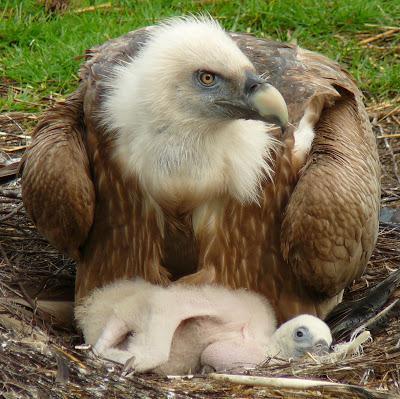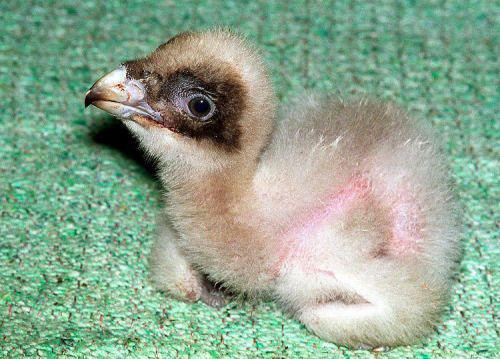The first image is the image on the left, the second image is the image on the right. Evaluate the accuracy of this statement regarding the images: "The images contain baby birds". Is it true? Answer yes or no. Yes. 